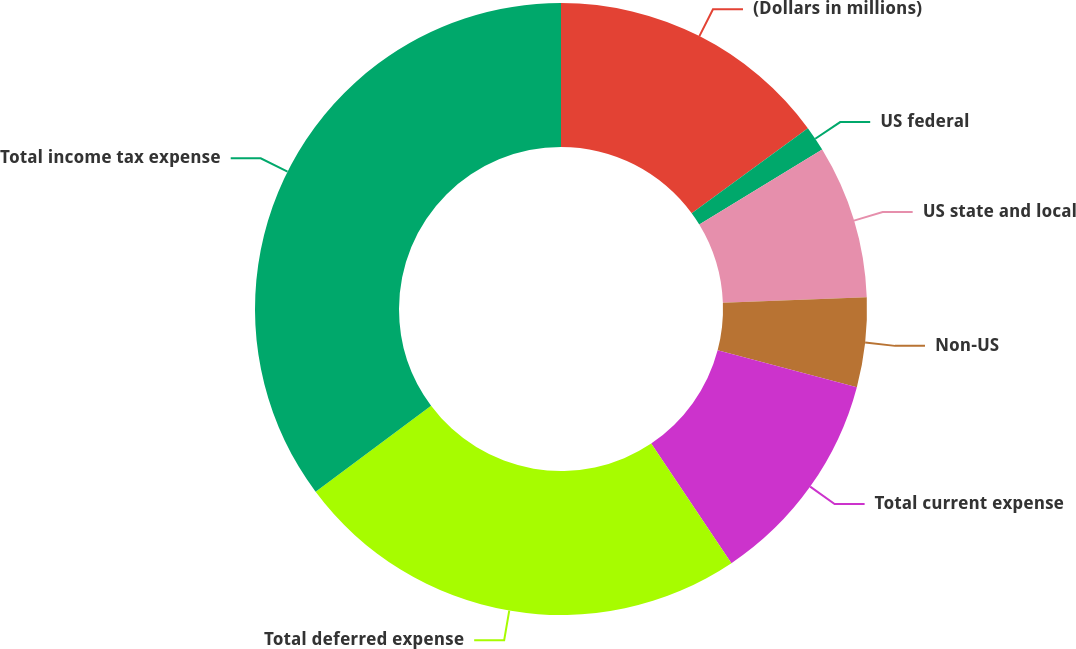Convert chart to OTSL. <chart><loc_0><loc_0><loc_500><loc_500><pie_chart><fcel>(Dollars in millions)<fcel>US federal<fcel>US state and local<fcel>Non-US<fcel>Total current expense<fcel>Total deferred expense<fcel>Total income tax expense<nl><fcel>14.94%<fcel>1.34%<fcel>8.11%<fcel>4.72%<fcel>11.49%<fcel>24.21%<fcel>35.19%<nl></chart> 